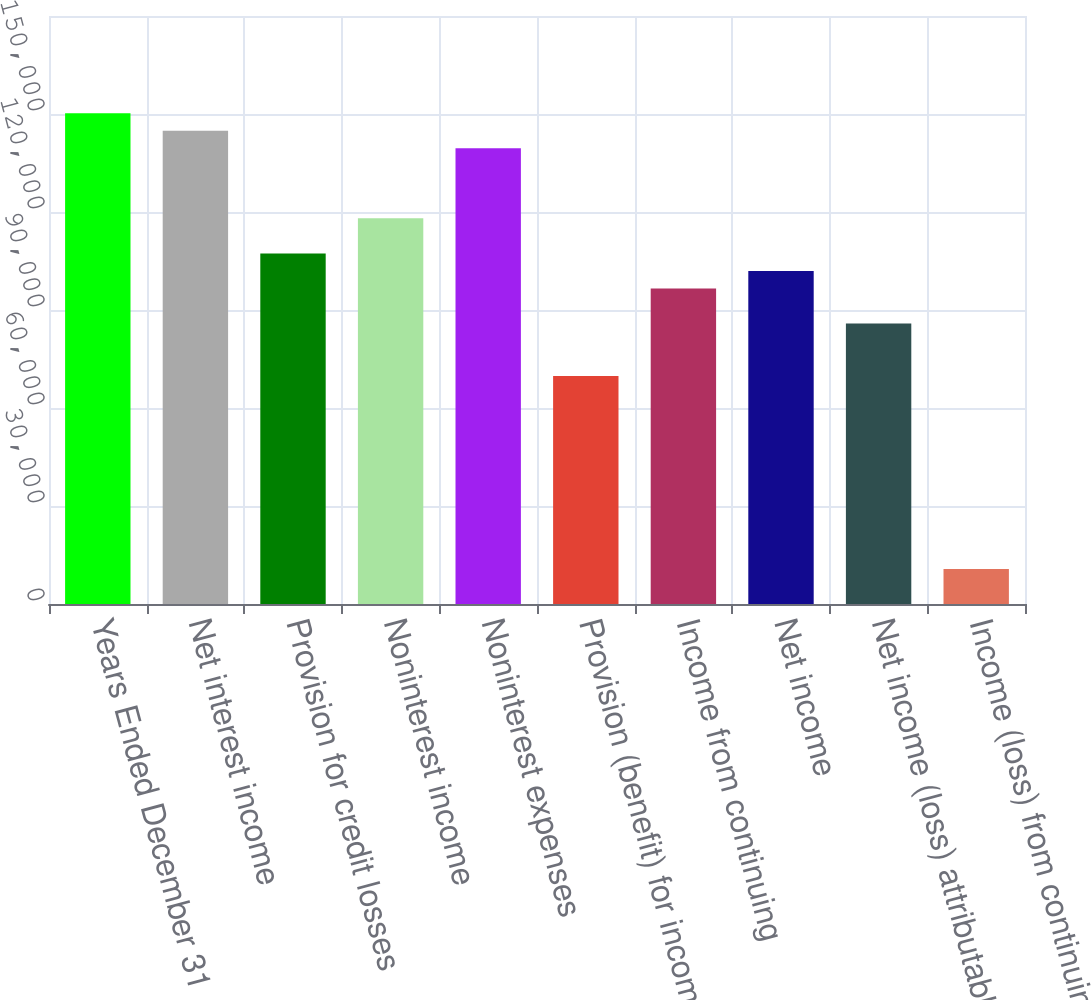Convert chart to OTSL. <chart><loc_0><loc_0><loc_500><loc_500><bar_chart><fcel>Years Ended December 31<fcel>Net interest income<fcel>Provision for credit losses<fcel>Noninterest income<fcel>Noninterest expenses<fcel>Provision (benefit) for income<fcel>Income from continuing<fcel>Net income<fcel>Net income (loss) attributable<fcel>Income (loss) from continuing<nl><fcel>150267<fcel>144901<fcel>107334<fcel>118067<fcel>139534<fcel>69767.1<fcel>96600.5<fcel>101967<fcel>85867.1<fcel>10733.6<nl></chart> 